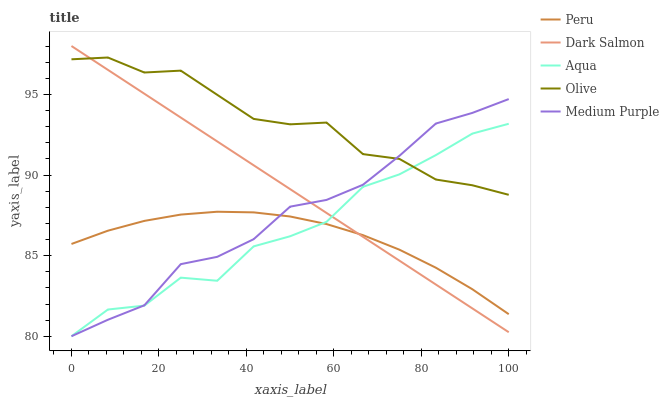Does Medium Purple have the minimum area under the curve?
Answer yes or no. No. Does Medium Purple have the maximum area under the curve?
Answer yes or no. No. Is Medium Purple the smoothest?
Answer yes or no. No. Is Medium Purple the roughest?
Answer yes or no. No. Does Dark Salmon have the lowest value?
Answer yes or no. No. Does Medium Purple have the highest value?
Answer yes or no. No. Is Peru less than Olive?
Answer yes or no. Yes. Is Olive greater than Peru?
Answer yes or no. Yes. Does Peru intersect Olive?
Answer yes or no. No. 